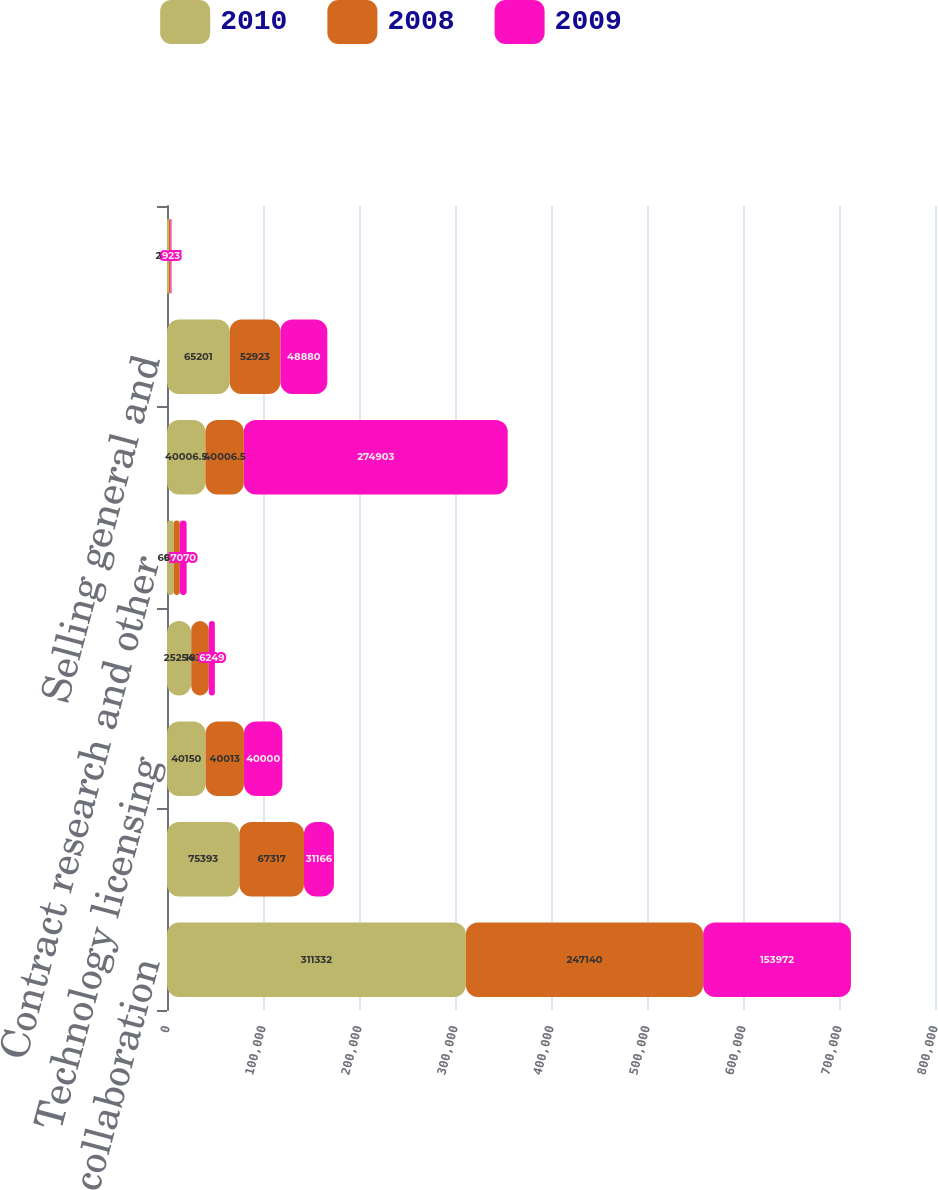Convert chart. <chart><loc_0><loc_0><loc_500><loc_500><stacked_bar_chart><ecel><fcel>Sanofi-aventis collaboration<fcel>Other collaboration revenue<fcel>Technology licensing<fcel>Net product sales<fcel>Contract research and other<fcel>Research and development<fcel>Selling general and<fcel>Cost of goods sold<nl><fcel>2010<fcel>311332<fcel>75393<fcel>40150<fcel>25254<fcel>6945<fcel>40006.5<fcel>65201<fcel>2093<nl><fcel>2008<fcel>247140<fcel>67317<fcel>40013<fcel>18364<fcel>6434<fcel>40006.5<fcel>52923<fcel>1686<nl><fcel>2009<fcel>153972<fcel>31166<fcel>40000<fcel>6249<fcel>7070<fcel>274903<fcel>48880<fcel>923<nl></chart> 